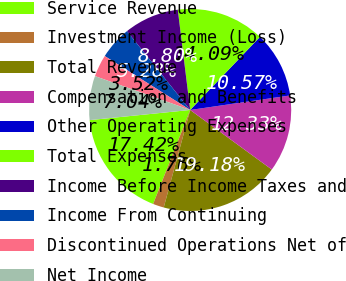Convert chart to OTSL. <chart><loc_0><loc_0><loc_500><loc_500><pie_chart><fcel>Service Revenue<fcel>Investment Income (Loss)<fcel>Total Revenue<fcel>Compensation and Benefits<fcel>Other Operating Expenses<fcel>Total Expenses<fcel>Income Before Income Taxes and<fcel>Income From Continuing<fcel>Discontinued Operations Net of<fcel>Net Income<nl><fcel>17.42%<fcel>1.76%<fcel>19.18%<fcel>12.33%<fcel>10.57%<fcel>14.09%<fcel>8.8%<fcel>5.28%<fcel>3.52%<fcel>7.04%<nl></chart> 